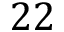Convert formula to latex. <formula><loc_0><loc_0><loc_500><loc_500>2 2</formula> 